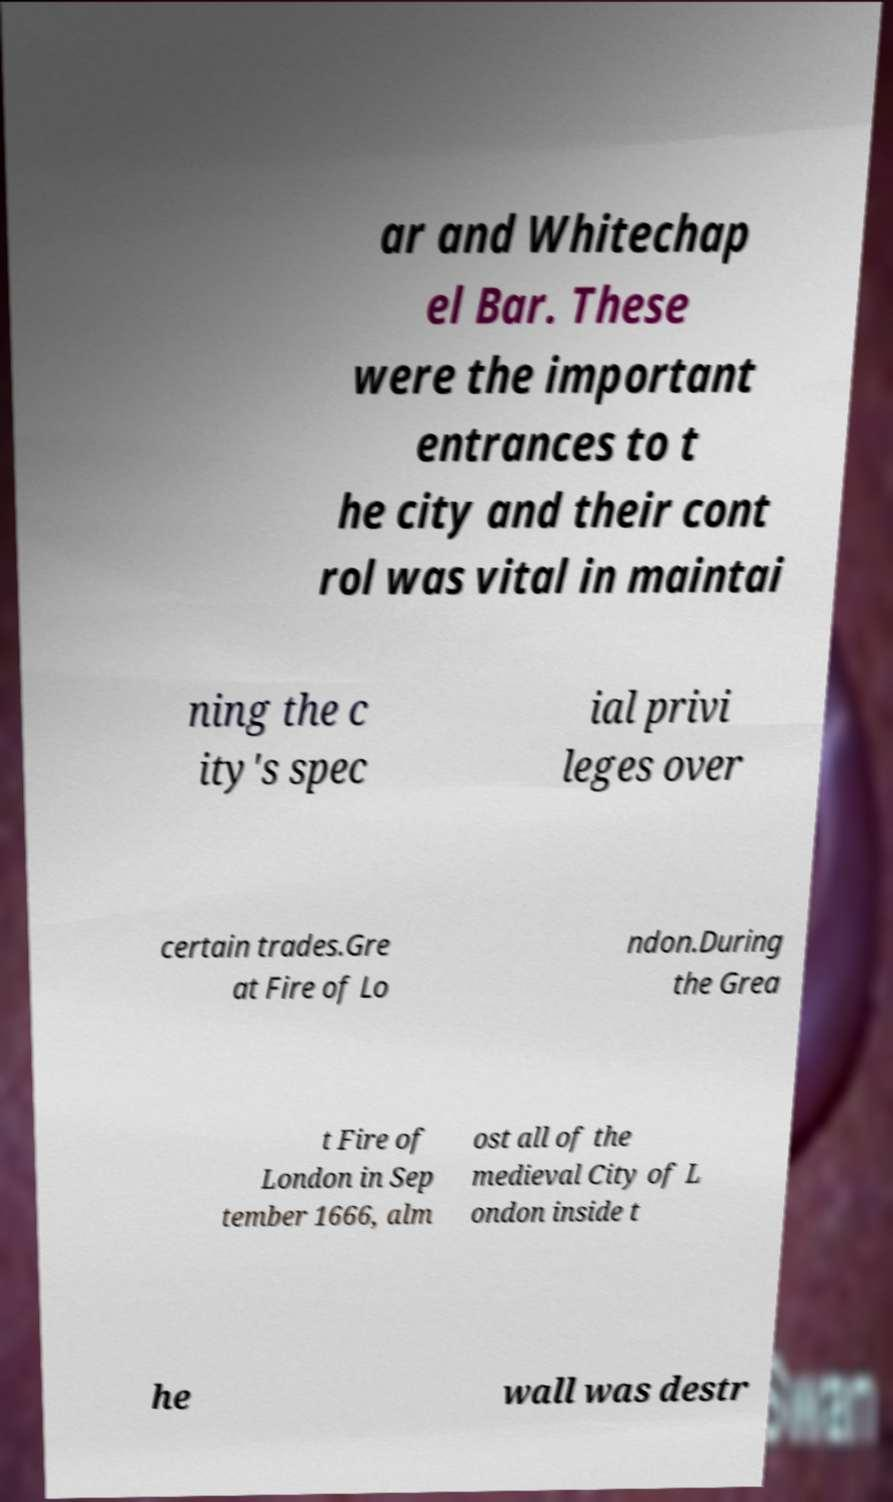For documentation purposes, I need the text within this image transcribed. Could you provide that? ar and Whitechap el Bar. These were the important entrances to t he city and their cont rol was vital in maintai ning the c ity's spec ial privi leges over certain trades.Gre at Fire of Lo ndon.During the Grea t Fire of London in Sep tember 1666, alm ost all of the medieval City of L ondon inside t he wall was destr 